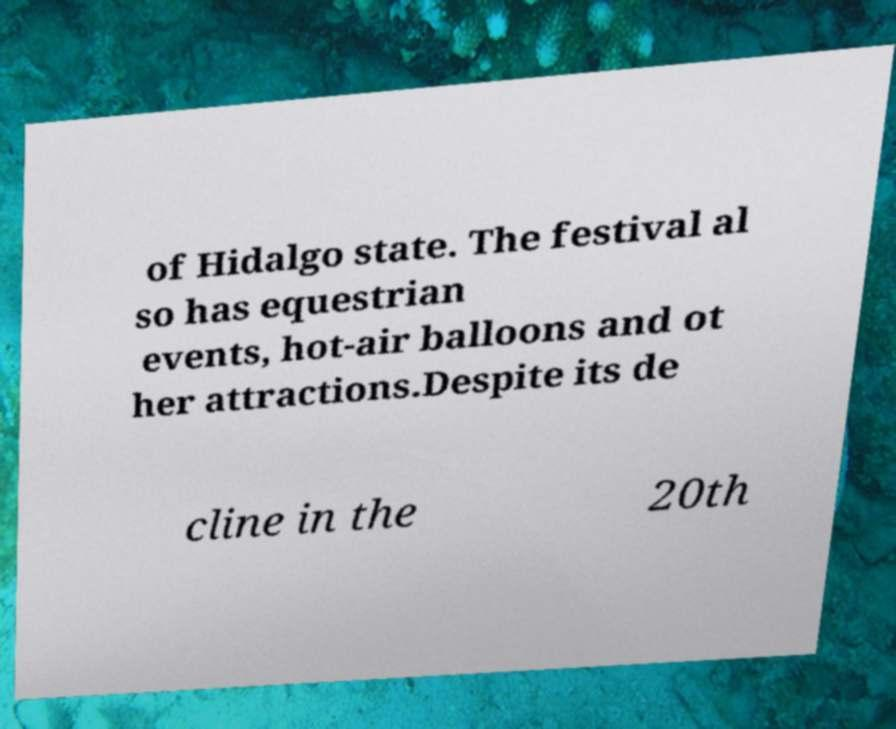Can you accurately transcribe the text from the provided image for me? of Hidalgo state. The festival al so has equestrian events, hot-air balloons and ot her attractions.Despite its de cline in the 20th 